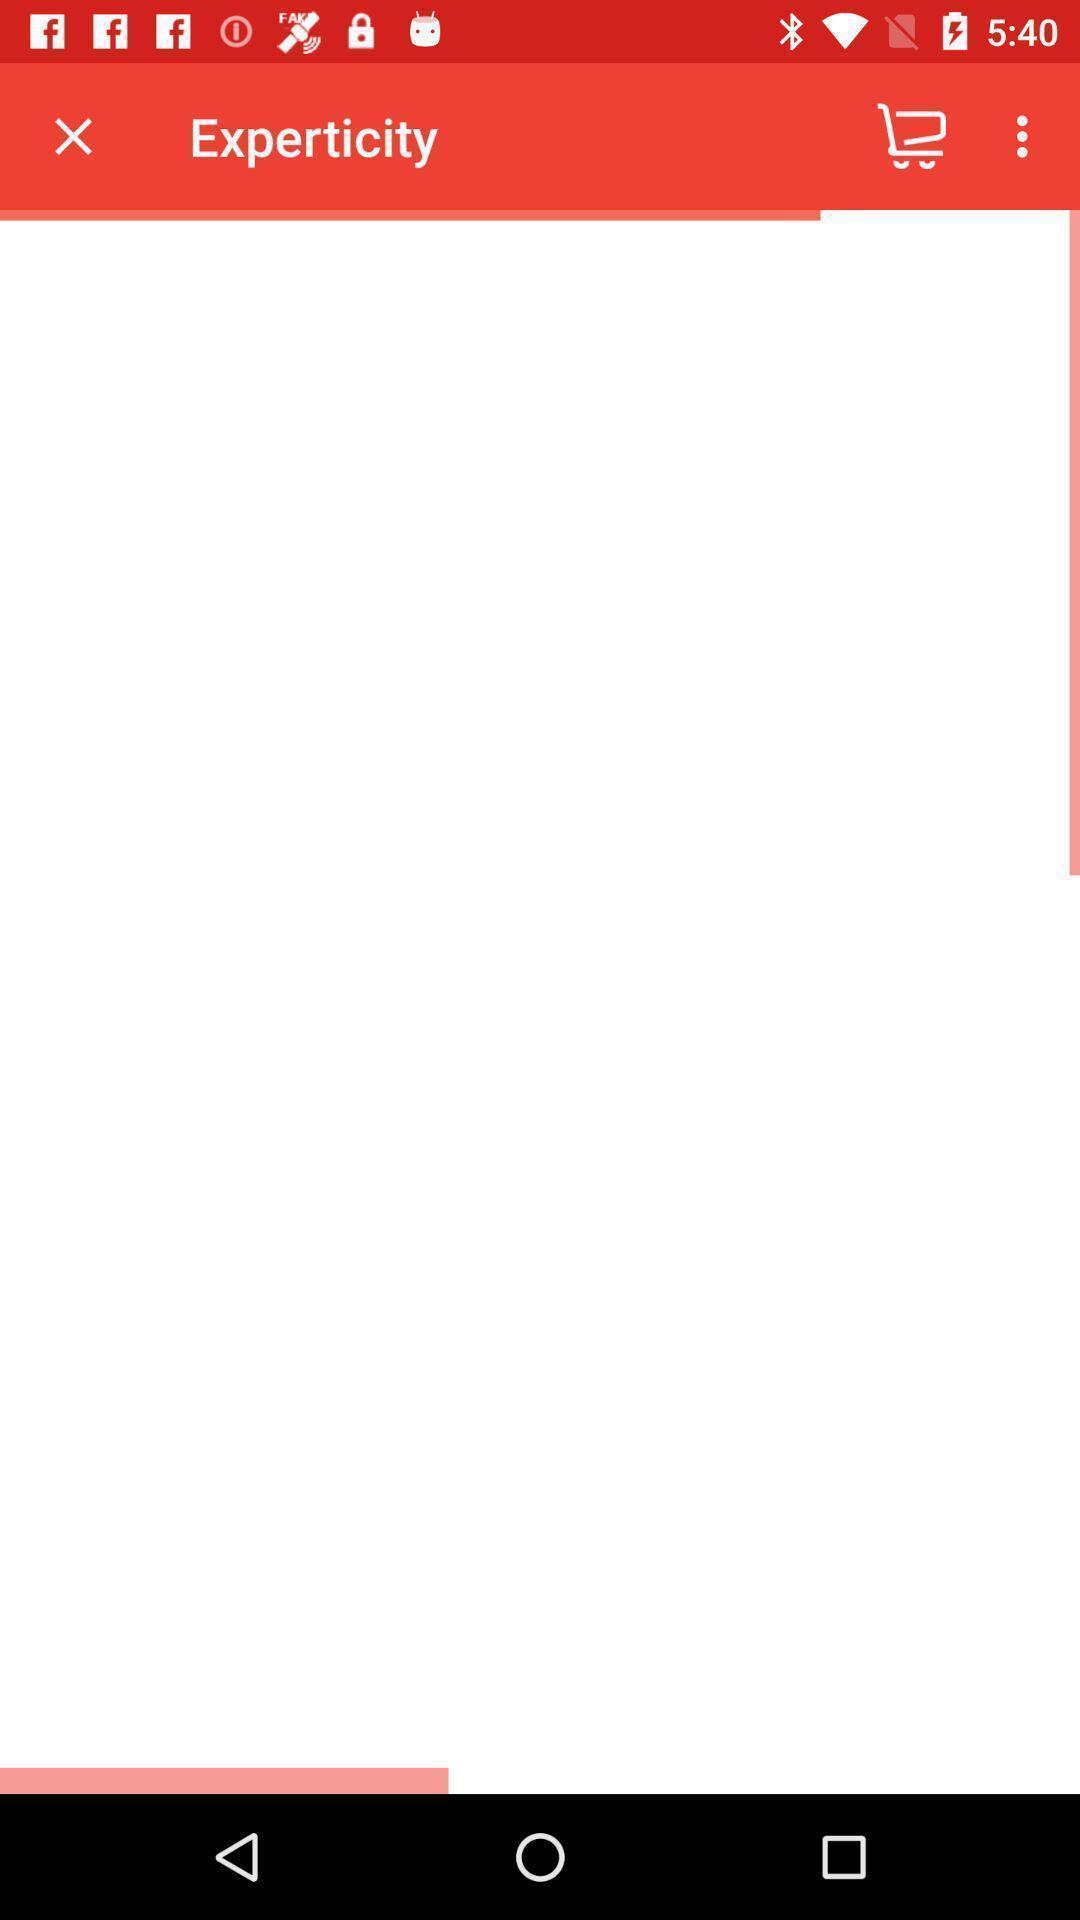What can you discern from this picture? Page that is still loading in an shopping app. 